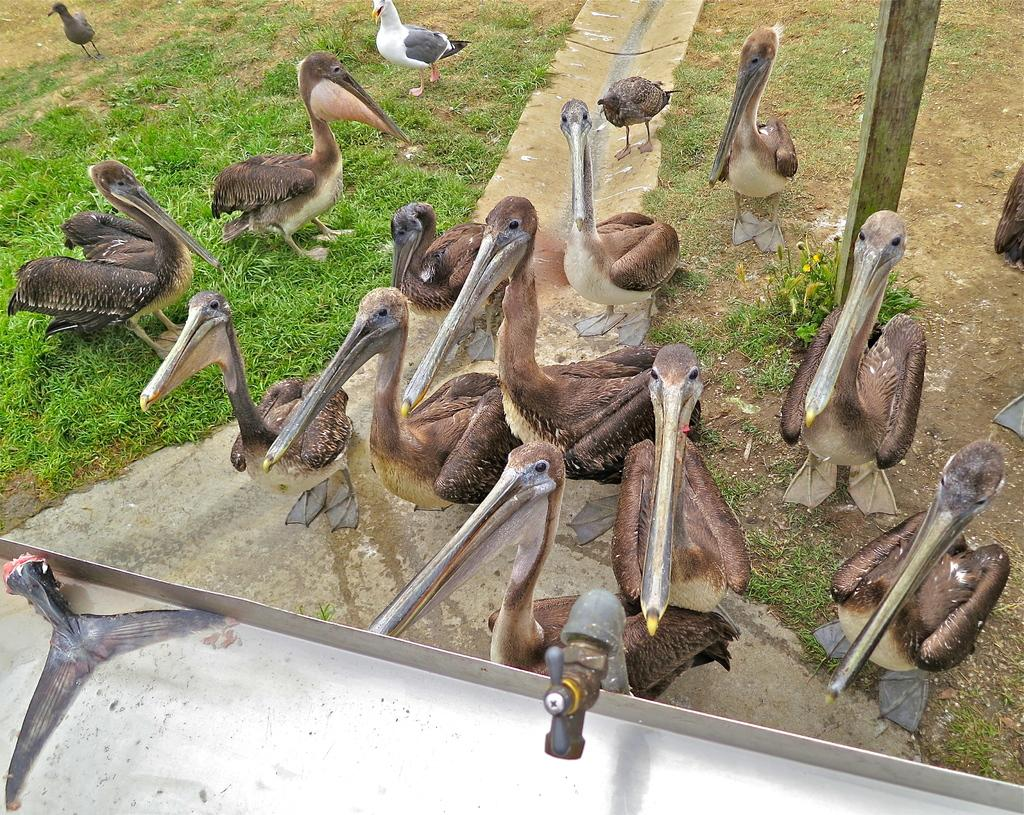What type of animals can be seen in the image? There are waterfowls in the image. Where are the waterfowls located? The waterfowls are on the grass land. What is the position of the waterfowls in the image? The waterfowls are in the center of the image. Can you describe any other objects or features in the image? There is a tap at the bottom side of the image. What shape is the pen that the waterfowls are using to draw in the image? There is no pen present in the image, and the waterfowls are not drawing. --- Facts: 1. There is a person holding a camera in the image. 2. The person is standing on a bridge. 3. The bridge is over a river. 4. There are trees in the background. 5. The sky is visible in the image. Absurd Topics: fish, bicycle, music Conversation: What is the person in the image holding? The person in the image is holding a camera. Where is the person standing in the image? The person is standing on a bridge. What is the bridge positioned over in the image? The bridge is over a river. What can be seen in the background of the image? There are trees in the background. What is visible in the sky in the image? The sky is visible in the image. Reasoning: Let's think step by step in order to produce the conversation. We start by identifying the main subject in the image, which is the person holding a camera. Then, we describe the person's location and the bridge's position in the image. Next, we mention the river and the background elements, such as trees. Finally, we acknowledge the presence of the sky. Each question is designed to elicit a specific detail about the image that is known from the provided facts. Absurd Question/Answer: What type of fish can be seen swimming in the river in the image? There is no fish visible in the river in the image. What kind of music is the person playing on the bicycle in the image? There is no bicycle or music present in the image. 